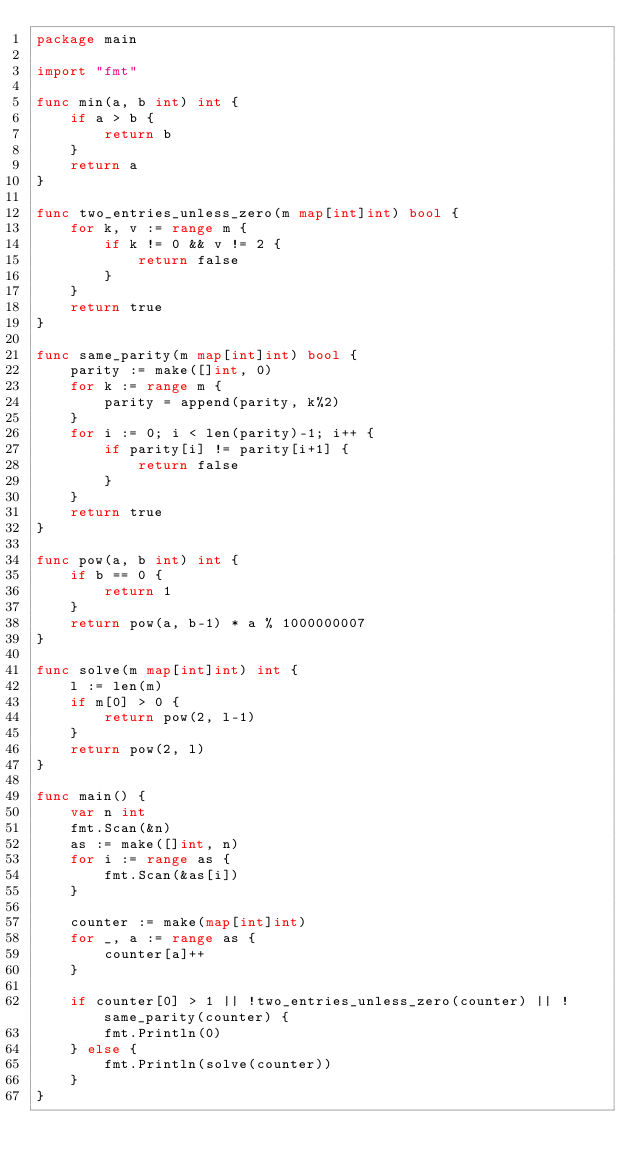<code> <loc_0><loc_0><loc_500><loc_500><_Go_>package main

import "fmt"

func min(a, b int) int {
	if a > b {
		return b
	}
	return a
}

func two_entries_unless_zero(m map[int]int) bool {
	for k, v := range m {
		if k != 0 && v != 2 {
			return false
		}
	}
	return true
}

func same_parity(m map[int]int) bool {
	parity := make([]int, 0)
	for k := range m {
		parity = append(parity, k%2)
	}
	for i := 0; i < len(parity)-1; i++ {
		if parity[i] != parity[i+1] {
			return false
		}
	}
	return true
}

func pow(a, b int) int {
	if b == 0 {
		return 1
	}
	return pow(a, b-1) * a % 1000000007
}

func solve(m map[int]int) int {
	l := len(m)
	if m[0] > 0 {
		return pow(2, l-1)
	}
	return pow(2, l)
}

func main() {
	var n int
	fmt.Scan(&n)
	as := make([]int, n)
	for i := range as {
		fmt.Scan(&as[i])
	}

	counter := make(map[int]int)
	for _, a := range as {
		counter[a]++
	}

	if counter[0] > 1 || !two_entries_unless_zero(counter) || !same_parity(counter) {
		fmt.Println(0)
	} else {
		fmt.Println(solve(counter))
	}
}
</code> 